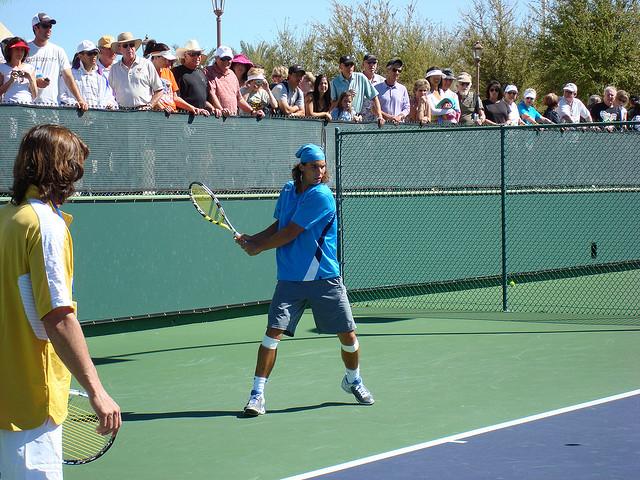Are these people angry?
Be succinct. No. Is he ready to serve?
Write a very short answer. No. What sport is he playing?
Be succinct. Tennis. Is there an audience?
Answer briefly. Yes. How many wearing hats?
Short answer required. 20. 